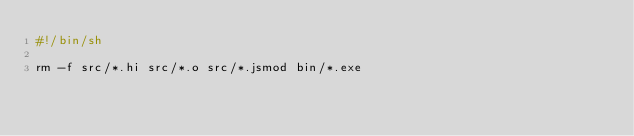Convert code to text. <code><loc_0><loc_0><loc_500><loc_500><_Bash_>#!/bin/sh

rm -f src/*.hi src/*.o src/*.jsmod bin/*.exe
</code> 